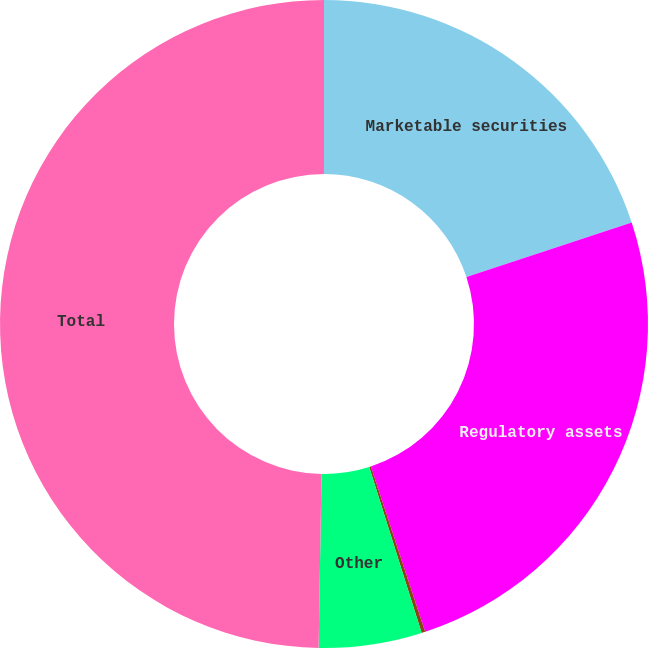Convert chart. <chart><loc_0><loc_0><loc_500><loc_500><pie_chart><fcel>Marketable securities<fcel>Regulatory assets<fcel>Assets from risk management<fcel>Other<fcel>Total<nl><fcel>19.93%<fcel>25.02%<fcel>0.18%<fcel>5.14%<fcel>49.74%<nl></chart> 